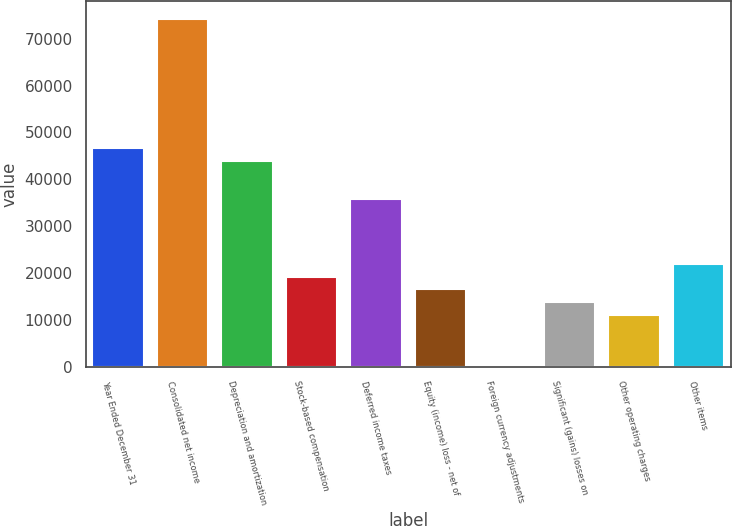<chart> <loc_0><loc_0><loc_500><loc_500><bar_chart><fcel>Year Ended December 31<fcel>Consolidated net income<fcel>Depreciation and amortization<fcel>Stock-based compensation<fcel>Deferred income taxes<fcel>Equity (income) loss - net of<fcel>Foreign currency adjustments<fcel>Significant (gains) losses on<fcel>Other operating charges<fcel>Other items<nl><fcel>46736.6<fcel>74224.6<fcel>43987.8<fcel>19248.6<fcel>35741.4<fcel>16499.8<fcel>7<fcel>13751<fcel>11002.2<fcel>21997.4<nl></chart> 